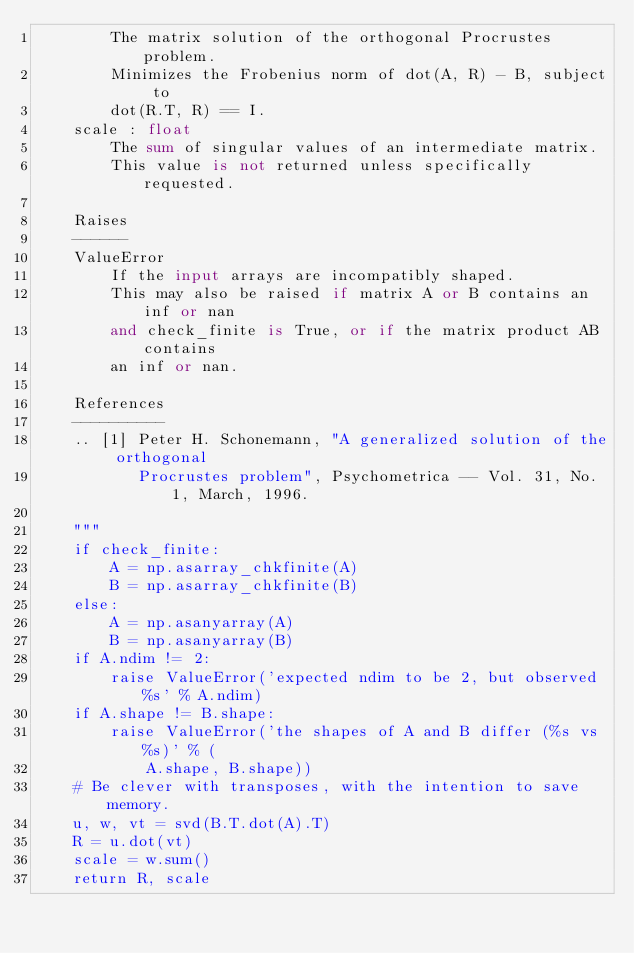<code> <loc_0><loc_0><loc_500><loc_500><_Python_>        The matrix solution of the orthogonal Procrustes problem.
        Minimizes the Frobenius norm of dot(A, R) - B, subject to
        dot(R.T, R) == I.
    scale : float
        The sum of singular values of an intermediate matrix.
        This value is not returned unless specifically requested.

    Raises
    ------
    ValueError
        If the input arrays are incompatibly shaped.
        This may also be raised if matrix A or B contains an inf or nan
        and check_finite is True, or if the matrix product AB contains
        an inf or nan.

    References
    ----------
    .. [1] Peter H. Schonemann, "A generalized solution of the orthogonal
           Procrustes problem", Psychometrica -- Vol. 31, No. 1, March, 1996.

    """
    if check_finite:
        A = np.asarray_chkfinite(A)
        B = np.asarray_chkfinite(B)
    else:
        A = np.asanyarray(A)
        B = np.asanyarray(B)
    if A.ndim != 2:
        raise ValueError('expected ndim to be 2, but observed %s' % A.ndim)
    if A.shape != B.shape:
        raise ValueError('the shapes of A and B differ (%s vs %s)' % (
            A.shape, B.shape))
    # Be clever with transposes, with the intention to save memory.
    u, w, vt = svd(B.T.dot(A).T)
    R = u.dot(vt)
    scale = w.sum()
    return R, scale
</code> 